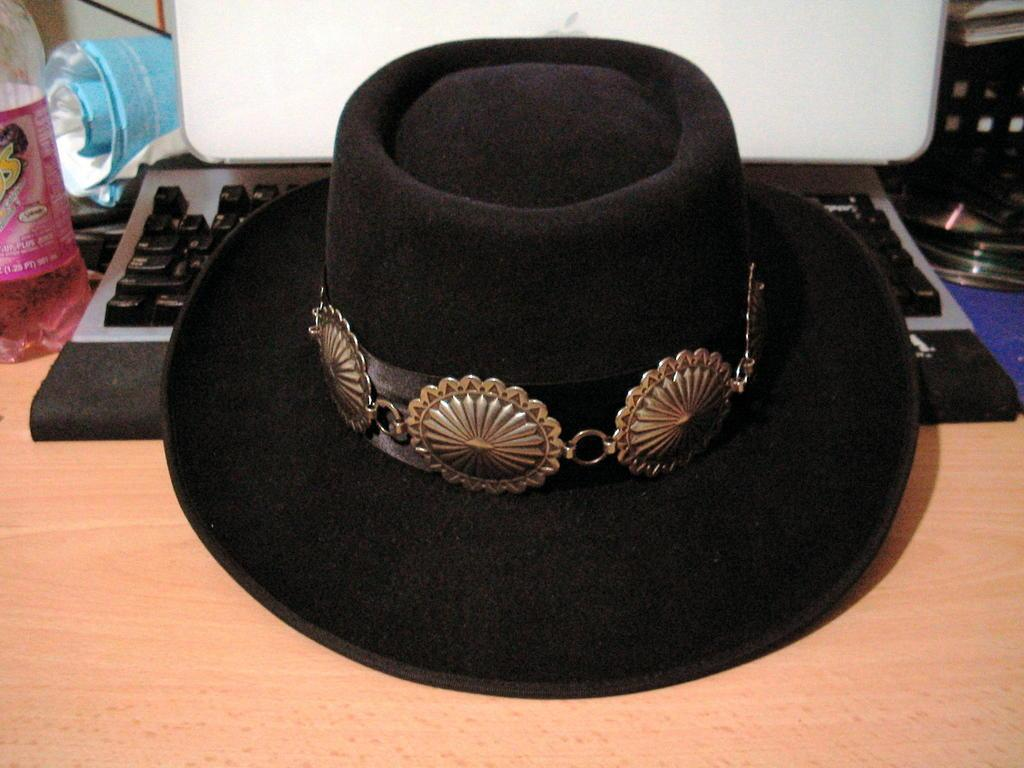What object can be seen in the image? There is a hat in the image. What can be seen in the background of the image? There is a keyboard in the background of the image. What type of glass is being used for the discovery in the image? There is no discovery or glass present in the image; it only features a hat and a keyboard. 